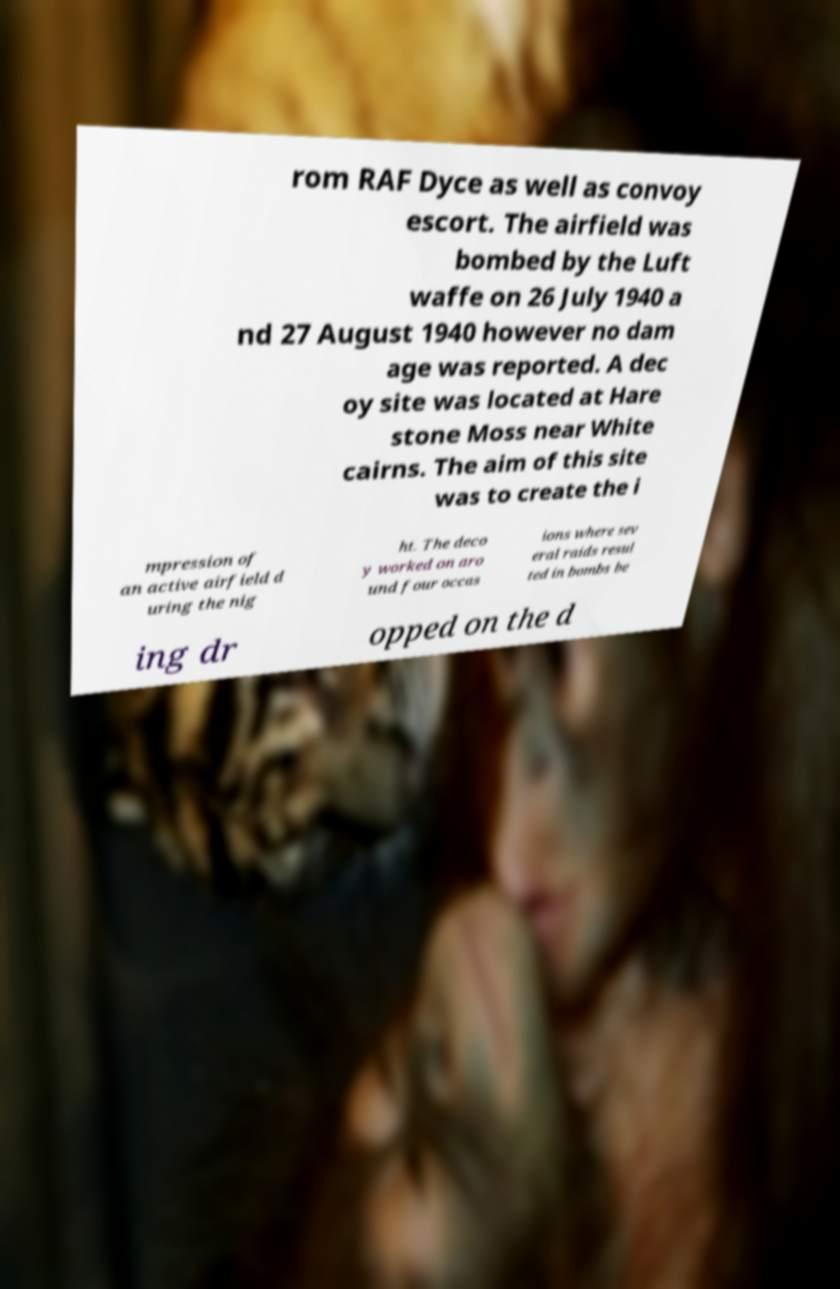Can you accurately transcribe the text from the provided image for me? rom RAF Dyce as well as convoy escort. The airfield was bombed by the Luft waffe on 26 July 1940 a nd 27 August 1940 however no dam age was reported. A dec oy site was located at Hare stone Moss near White cairns. The aim of this site was to create the i mpression of an active airfield d uring the nig ht. The deco y worked on aro und four occas ions where sev eral raids resul ted in bombs be ing dr opped on the d 